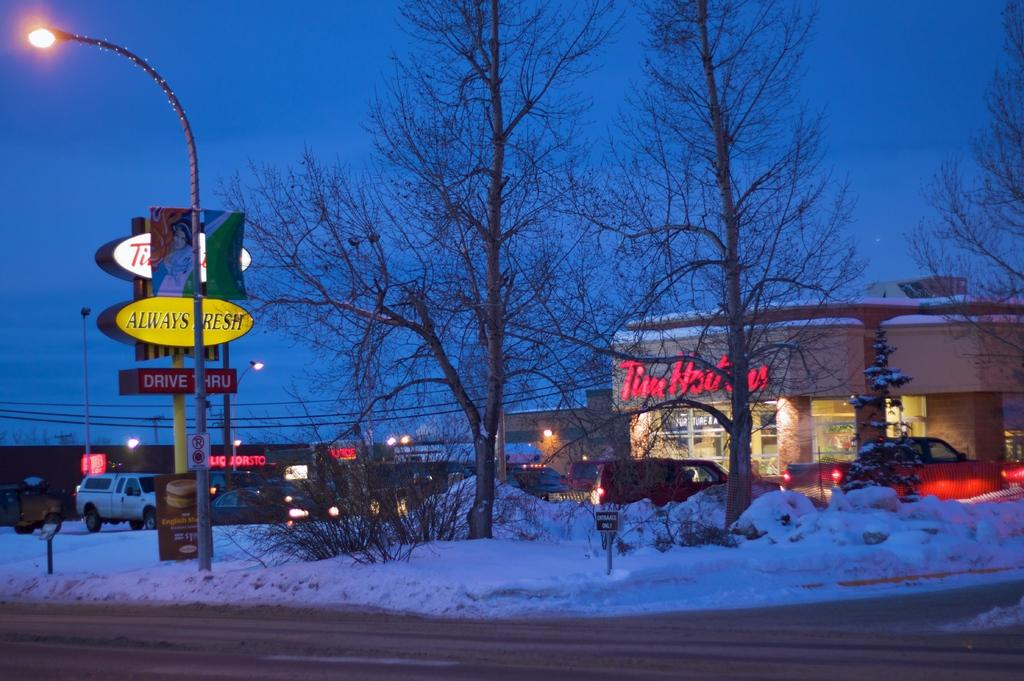<image>
Render a clear and concise summary of the photo. A shopping plaza has snow on the ground around it and a building that says Tim Hortons. 